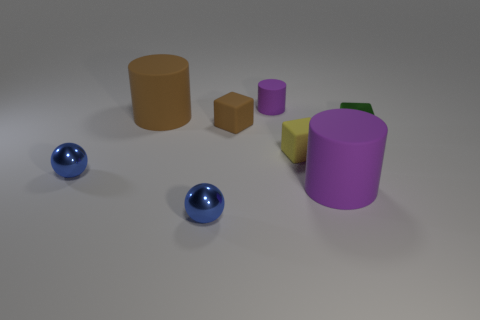Subtract all brown cylinders. How many cylinders are left? 2 Add 2 big purple matte things. How many objects exist? 10 Subtract all purple cylinders. How many cylinders are left? 1 Subtract all balls. How many objects are left? 6 Subtract 1 balls. How many balls are left? 1 Subtract all yellow spheres. Subtract all yellow cylinders. How many spheres are left? 2 Subtract all purple cylinders. How many brown spheres are left? 0 Subtract all cubes. Subtract all tiny red matte cubes. How many objects are left? 5 Add 1 large cylinders. How many large cylinders are left? 3 Add 4 large brown cylinders. How many large brown cylinders exist? 5 